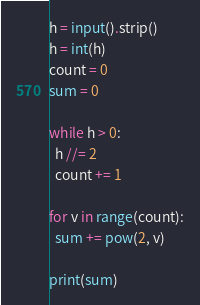Convert code to text. <code><loc_0><loc_0><loc_500><loc_500><_Python_>h = input().strip()
h = int(h)
count = 0
sum = 0

while h > 0:
  h //= 2
  count += 1
  
for v in range(count):
  sum += pow(2, v)
  
print(sum)</code> 